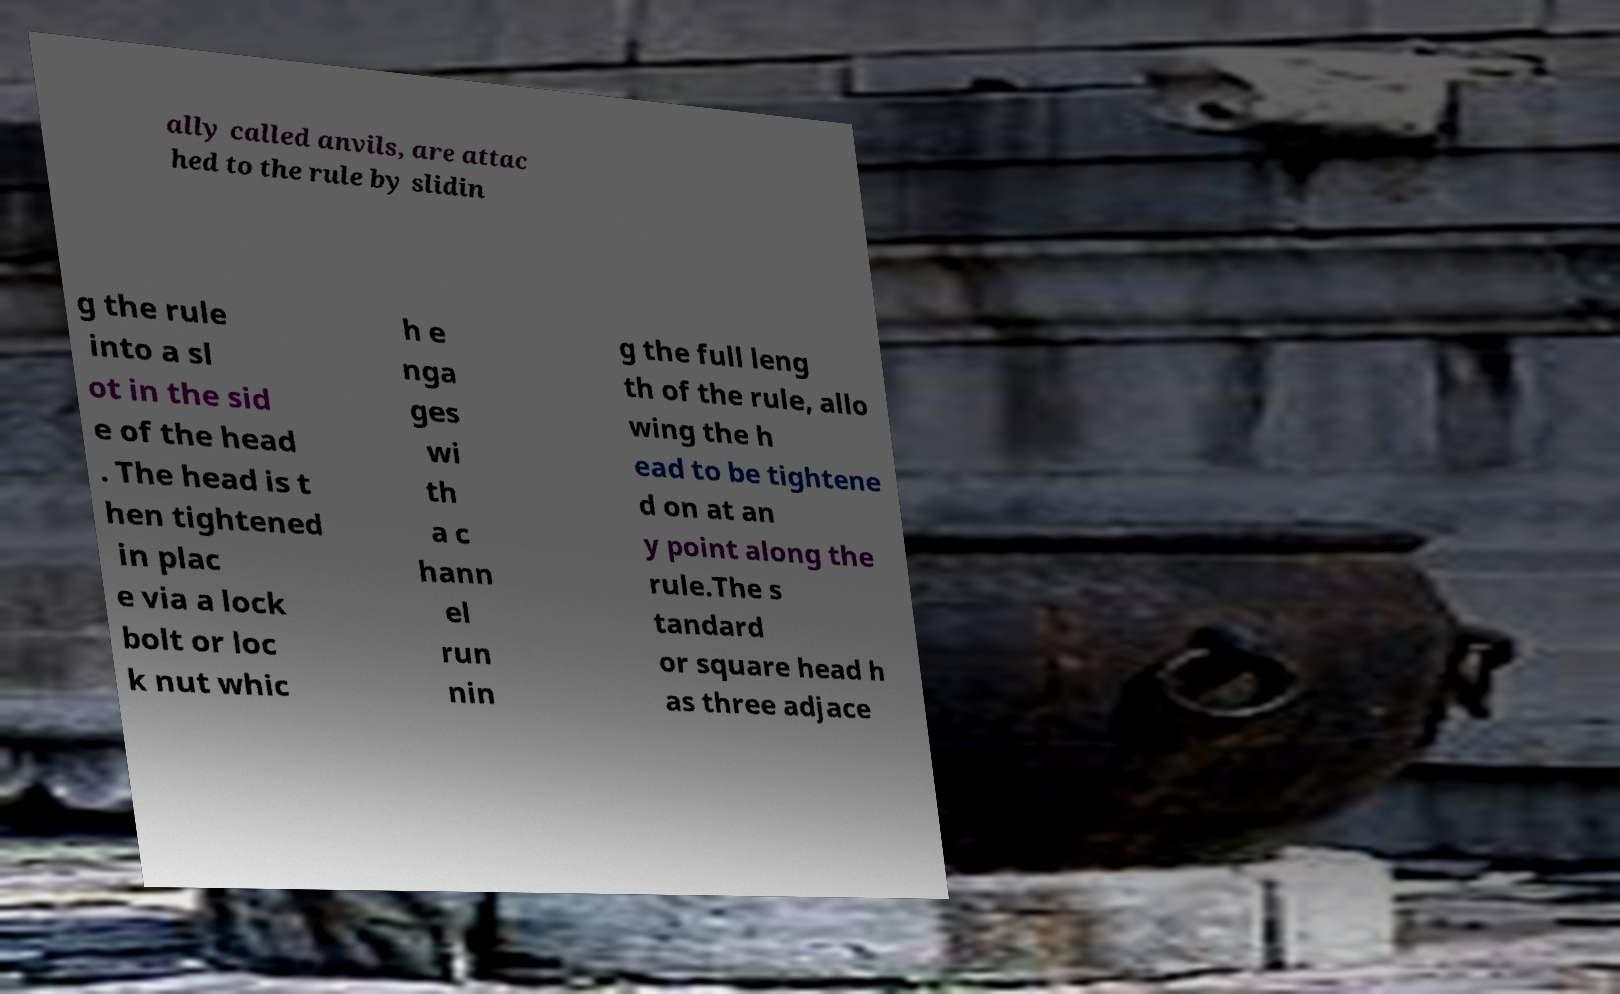I need the written content from this picture converted into text. Can you do that? ally called anvils, are attac hed to the rule by slidin g the rule into a sl ot in the sid e of the head . The head is t hen tightened in plac e via a lock bolt or loc k nut whic h e nga ges wi th a c hann el run nin g the full leng th of the rule, allo wing the h ead to be tightene d on at an y point along the rule.The s tandard or square head h as three adjace 